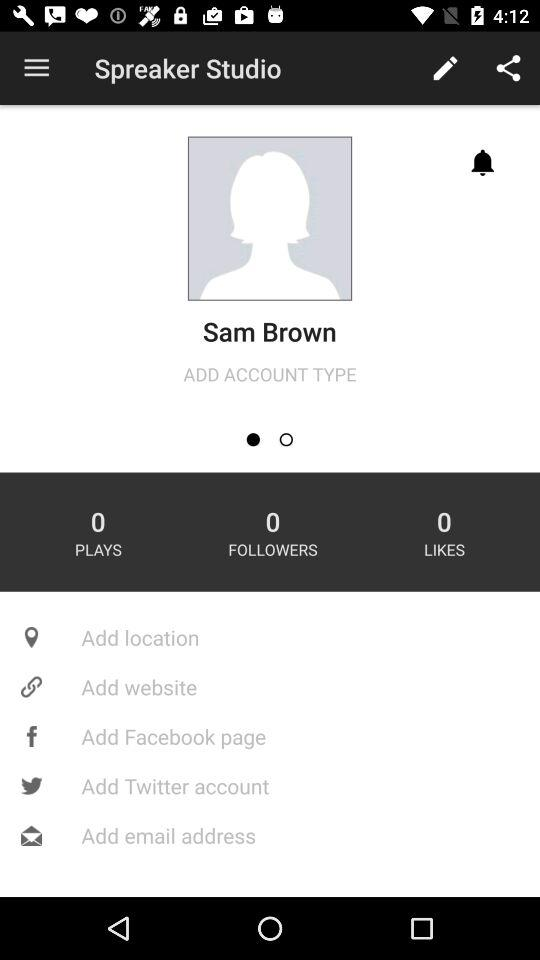What is the user name? The user name is Sam Brown. 